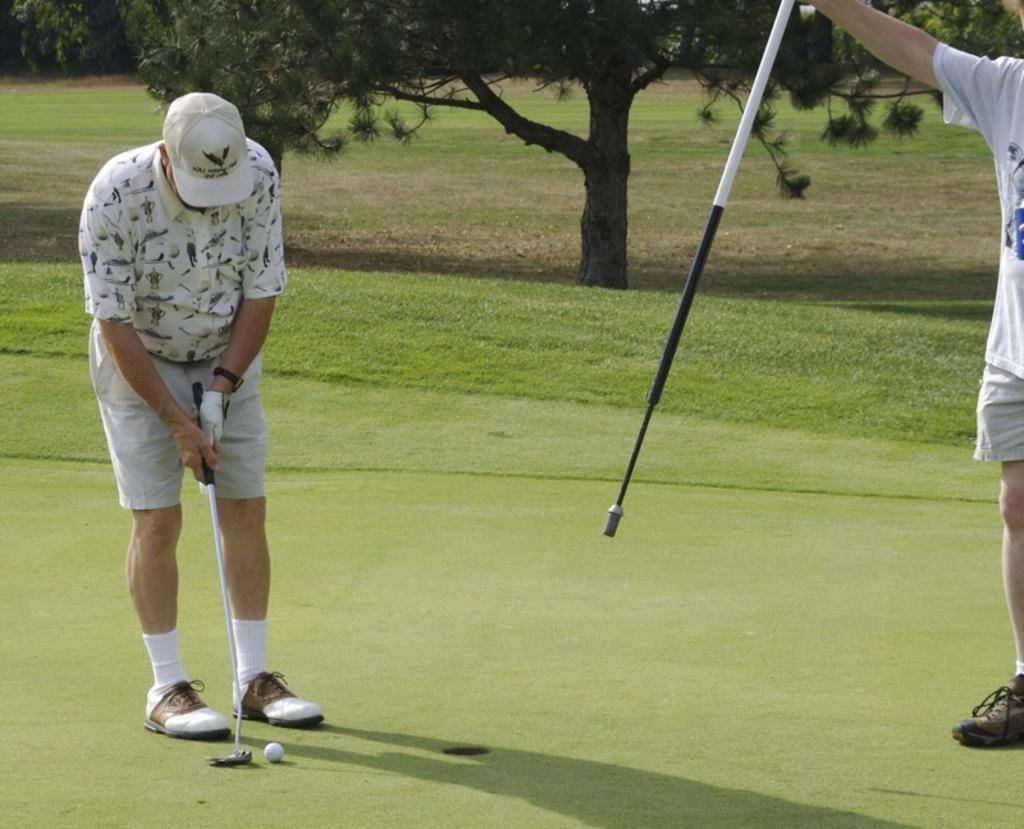How many people are in the image? There are two people in the image. What are the people holding in the image? The people are holding objects. What is on the ground in the image? There is a ball on the ground in the image. What type of natural environment is visible in the image? Grass and trees are visible in the image. What type of surprise can be seen in the image? There is no surprise present in the image. Are there any plastic objects visible in the image? The provided facts do not mention any plastic objects in the image. How many ducks are visible in the image? There are no ducks present in the image. 